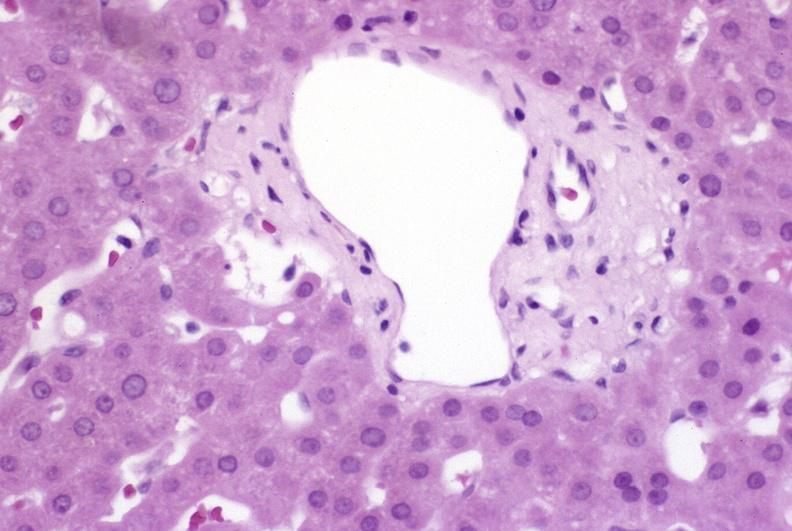does this image show ductopenia?
Answer the question using a single word or phrase. Yes 